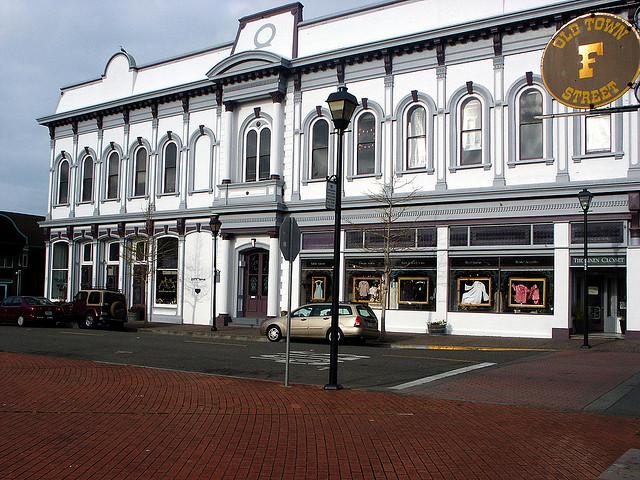Is that building fancy?
Write a very short answer. Yes. Where is the car parked in the picture?
Quick response, please. At curb. What is the street name in this photo?
Concise answer only. Old town street. 